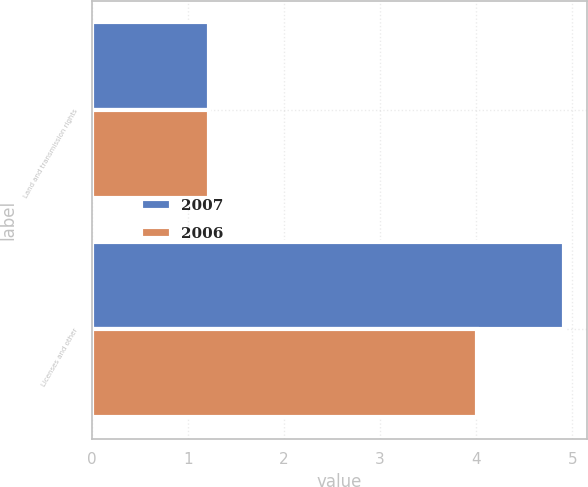Convert chart to OTSL. <chart><loc_0><loc_0><loc_500><loc_500><stacked_bar_chart><ecel><fcel>Land and transmission rights<fcel>Licenses and other<nl><fcel>2007<fcel>1.22<fcel>4.91<nl><fcel>2006<fcel>1.22<fcel>4.01<nl></chart> 